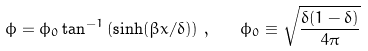Convert formula to latex. <formula><loc_0><loc_0><loc_500><loc_500>\phi = \phi _ { 0 } \tan ^ { - 1 } \left ( \sinh ( \beta x / \delta ) \right ) \, , \quad \phi _ { 0 } \equiv \sqrt { \frac { \delta ( 1 - \delta ) } { 4 \pi } }</formula> 